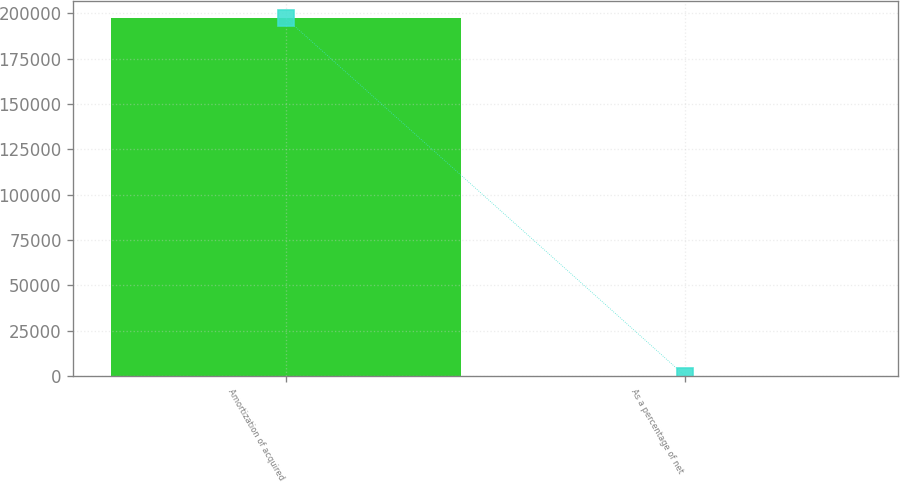Convert chart. <chart><loc_0><loc_0><loc_500><loc_500><bar_chart><fcel>Amortization of acquired<fcel>As a percentage of net<nl><fcel>197078<fcel>3.3<nl></chart> 